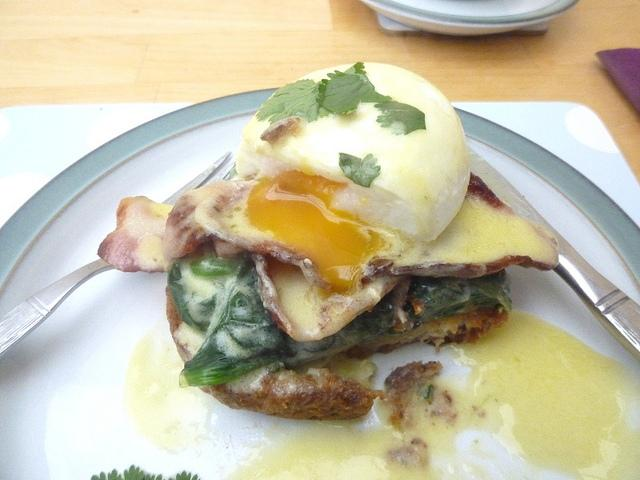What is near the top of the food pile?

Choices:
A) egg
B) cabbage
C) hot dog
D) apple egg 